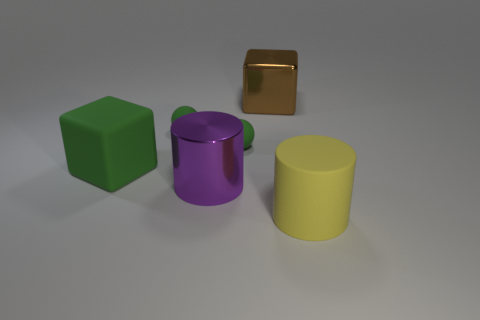Add 1 big yellow rubber cylinders. How many objects exist? 7 Subtract 2 cylinders. How many cylinders are left? 0 Subtract all cylinders. How many objects are left? 4 Subtract all tiny gray matte things. Subtract all purple cylinders. How many objects are left? 5 Add 3 brown objects. How many brown objects are left? 4 Add 2 small brown metal blocks. How many small brown metal blocks exist? 2 Subtract 0 red blocks. How many objects are left? 6 Subtract all purple cylinders. Subtract all yellow blocks. How many cylinders are left? 1 